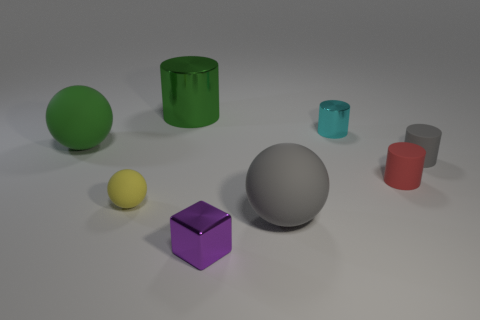How many things are either small yellow rubber objects or metallic cylinders that are to the right of the large gray matte sphere?
Provide a short and direct response. 2. There is a gray thing that is the same shape as the green rubber object; what size is it?
Give a very brief answer. Large. There is a tiny cyan metallic cylinder; are there any gray things to the left of it?
Your answer should be compact. Yes. There is a cylinder to the right of the red matte cylinder; is it the same color as the large rubber sphere that is behind the large gray object?
Ensure brevity in your answer.  No. Is there a tiny rubber object of the same shape as the green metal object?
Provide a succinct answer. Yes. What number of other objects are there of the same color as the small cube?
Your response must be concise. 0. There is a sphere right of the tiny matte object to the left of the shiny object in front of the small red rubber thing; what color is it?
Keep it short and to the point. Gray. Are there an equal number of large green things that are to the right of the small red object and gray matte cubes?
Your answer should be very brief. Yes. Is the size of the gray matte thing that is to the left of the cyan object the same as the big green metallic cylinder?
Your answer should be very brief. Yes. What number of cylinders are there?
Your answer should be compact. 4. 